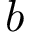<formula> <loc_0><loc_0><loc_500><loc_500>b</formula> 